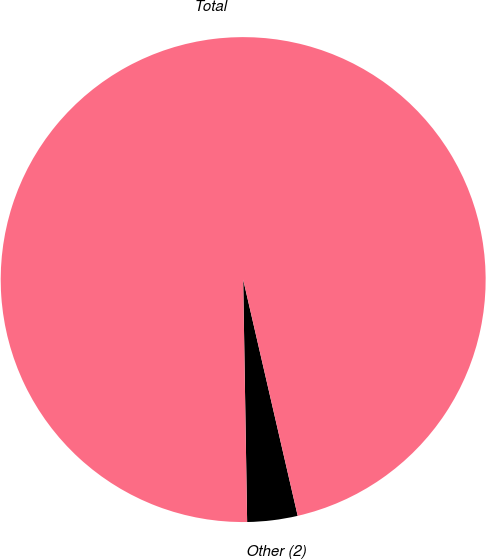Convert chart to OTSL. <chart><loc_0><loc_0><loc_500><loc_500><pie_chart><fcel>Other (2)<fcel>Total<nl><fcel>3.35%<fcel>96.65%<nl></chart> 